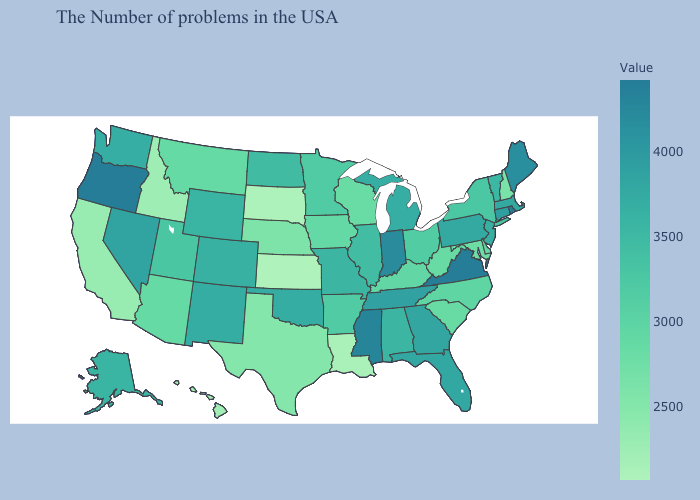Is the legend a continuous bar?
Quick response, please. Yes. Which states hav the highest value in the Northeast?
Concise answer only. Rhode Island. Among the states that border Texas , which have the lowest value?
Answer briefly. Louisiana. Does Louisiana have the lowest value in the South?
Keep it brief. Yes. Which states hav the highest value in the West?
Keep it brief. Oregon. Among the states that border Delaware , does Pennsylvania have the lowest value?
Quick response, please. No. Does Vermont have the highest value in the Northeast?
Be succinct. No. 